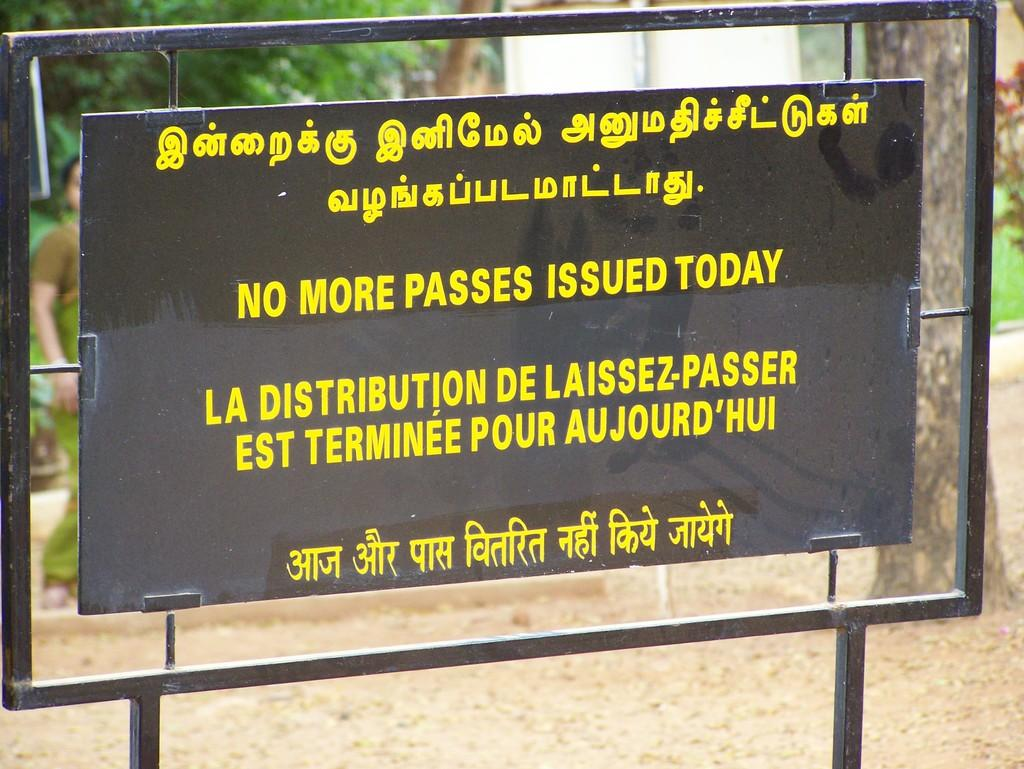<image>
Give a short and clear explanation of the subsequent image. A black and yellow sign states that there are no more passes issued today. 